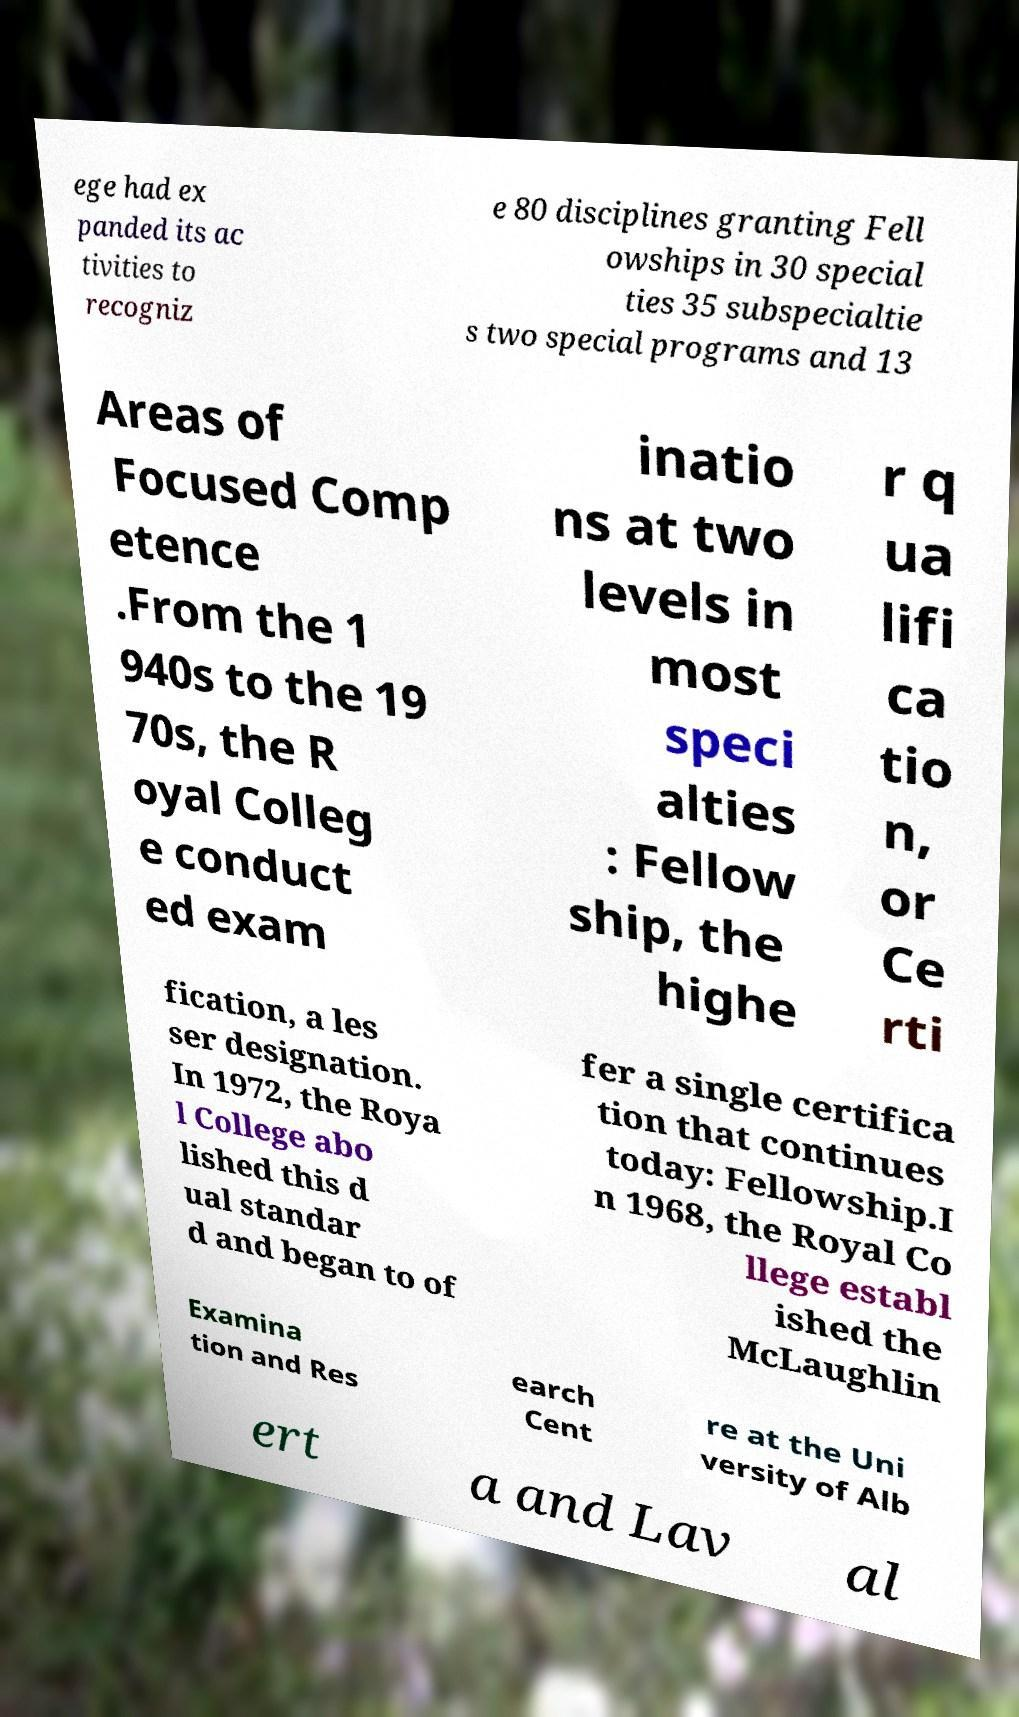Can you accurately transcribe the text from the provided image for me? ege had ex panded its ac tivities to recogniz e 80 disciplines granting Fell owships in 30 special ties 35 subspecialtie s two special programs and 13 Areas of Focused Comp etence .From the 1 940s to the 19 70s, the R oyal Colleg e conduct ed exam inatio ns at two levels in most speci alties : Fellow ship, the highe r q ua lifi ca tio n, or Ce rti fication, a les ser designation. In 1972, the Roya l College abo lished this d ual standar d and began to of fer a single certifica tion that continues today: Fellowship.I n 1968, the Royal Co llege establ ished the McLaughlin Examina tion and Res earch Cent re at the Uni versity of Alb ert a and Lav al 